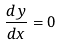<formula> <loc_0><loc_0><loc_500><loc_500>\frac { d y } { d x } = 0</formula> 